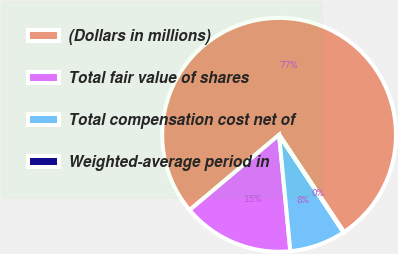<chart> <loc_0><loc_0><loc_500><loc_500><pie_chart><fcel>(Dollars in millions)<fcel>Total fair value of shares<fcel>Total compensation cost net of<fcel>Weighted-average period in<nl><fcel>76.76%<fcel>15.41%<fcel>7.75%<fcel>0.08%<nl></chart> 